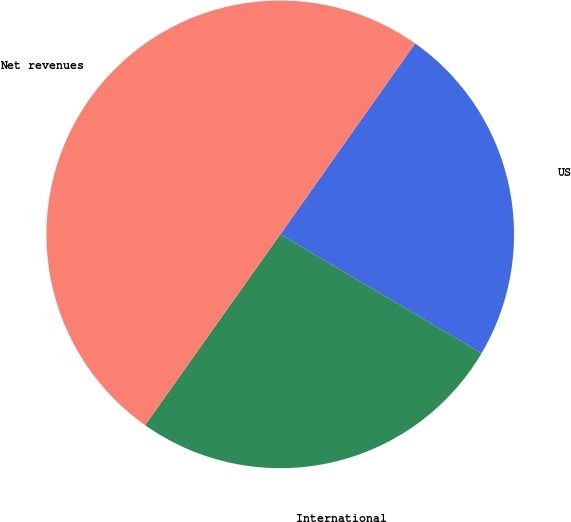Convert chart. <chart><loc_0><loc_0><loc_500><loc_500><pie_chart><fcel>US<fcel>International<fcel>Net revenues<nl><fcel>23.7%<fcel>26.32%<fcel>49.98%<nl></chart> 